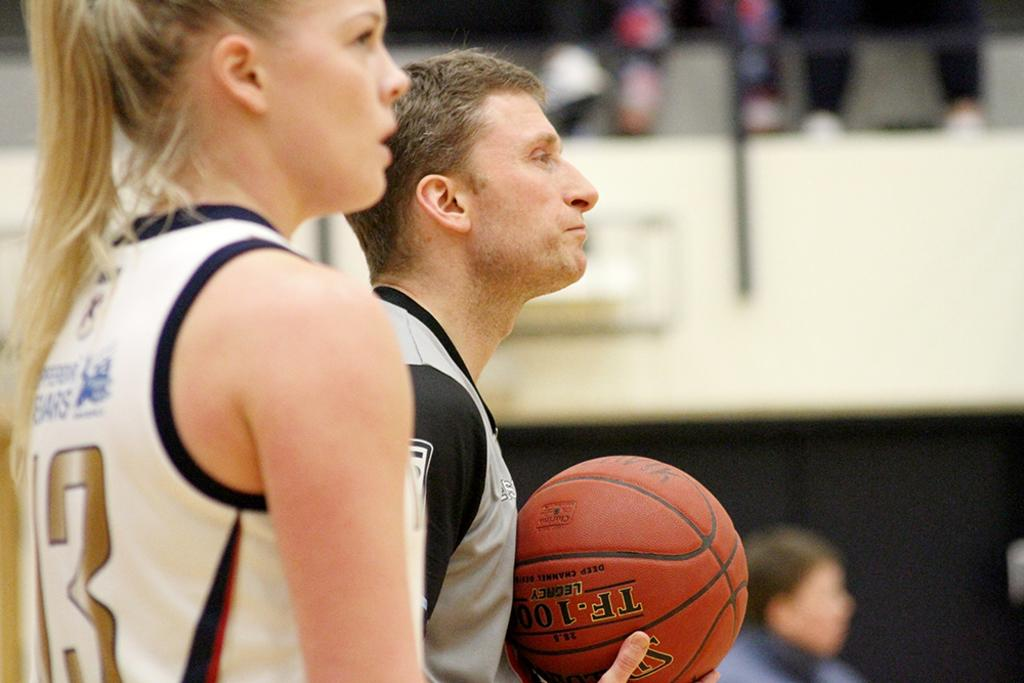<image>
Relay a brief, clear account of the picture shown. A basketball in a man's hand has the word legacy on it. 